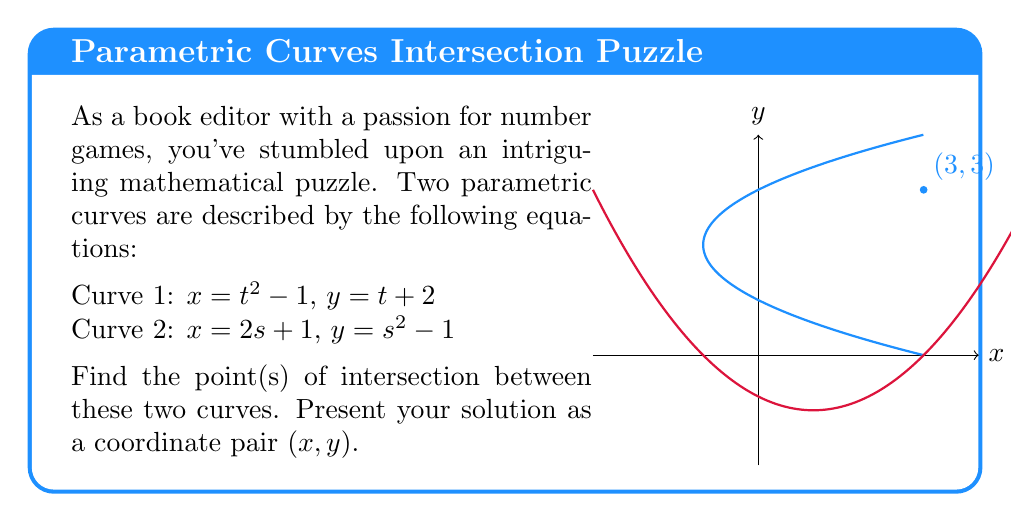Show me your answer to this math problem. Let's approach this step-by-step:

1) To find the intersection point(s), we need to equate the x and y coordinates of both curves:

   $t^2 - 1 = 2s + 1$ (equating x)
   $t + 2 = s^2 - 1$ (equating y)

2) From the second equation:
   $t = s^2 - 3$

3) Substitute this into the first equation:
   $(s^2 - 3)^2 - 1 = 2s + 1$

4) Expand:
   $s^4 - 6s^2 + 9 - 1 = 2s + 1$
   $s^4 - 6s^2 + 7 = 2s$

5) Rearrange:
   $s^4 - 6s^2 - 2s + 7 = 0$

6) This is a 4th degree polynomial equation. It's not easily solvable by factoring, but we can guess one solution: $s = 1$

7) If $s = 1$, then $t = 1^2 - 3 = -2$

8) Verify:
   For Curve 1: $x = (-2)^2 - 1 = 3$, $y = -2 + 2 = 0$
   For Curve 2: $x = 2(1) + 1 = 3$, $y = 1^2 - 1 = 0$

9) Therefore, the point of intersection is $(3, 0)$

Note: There might be other solutions to the equation, but $(3, 0)$ is definitely one point of intersection.
Answer: $(3, 0)$ 